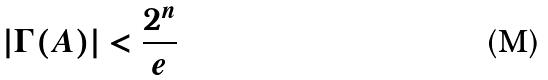<formula> <loc_0><loc_0><loc_500><loc_500>| \Gamma ( A ) | < \frac { 2 ^ { n } } { e }</formula> 